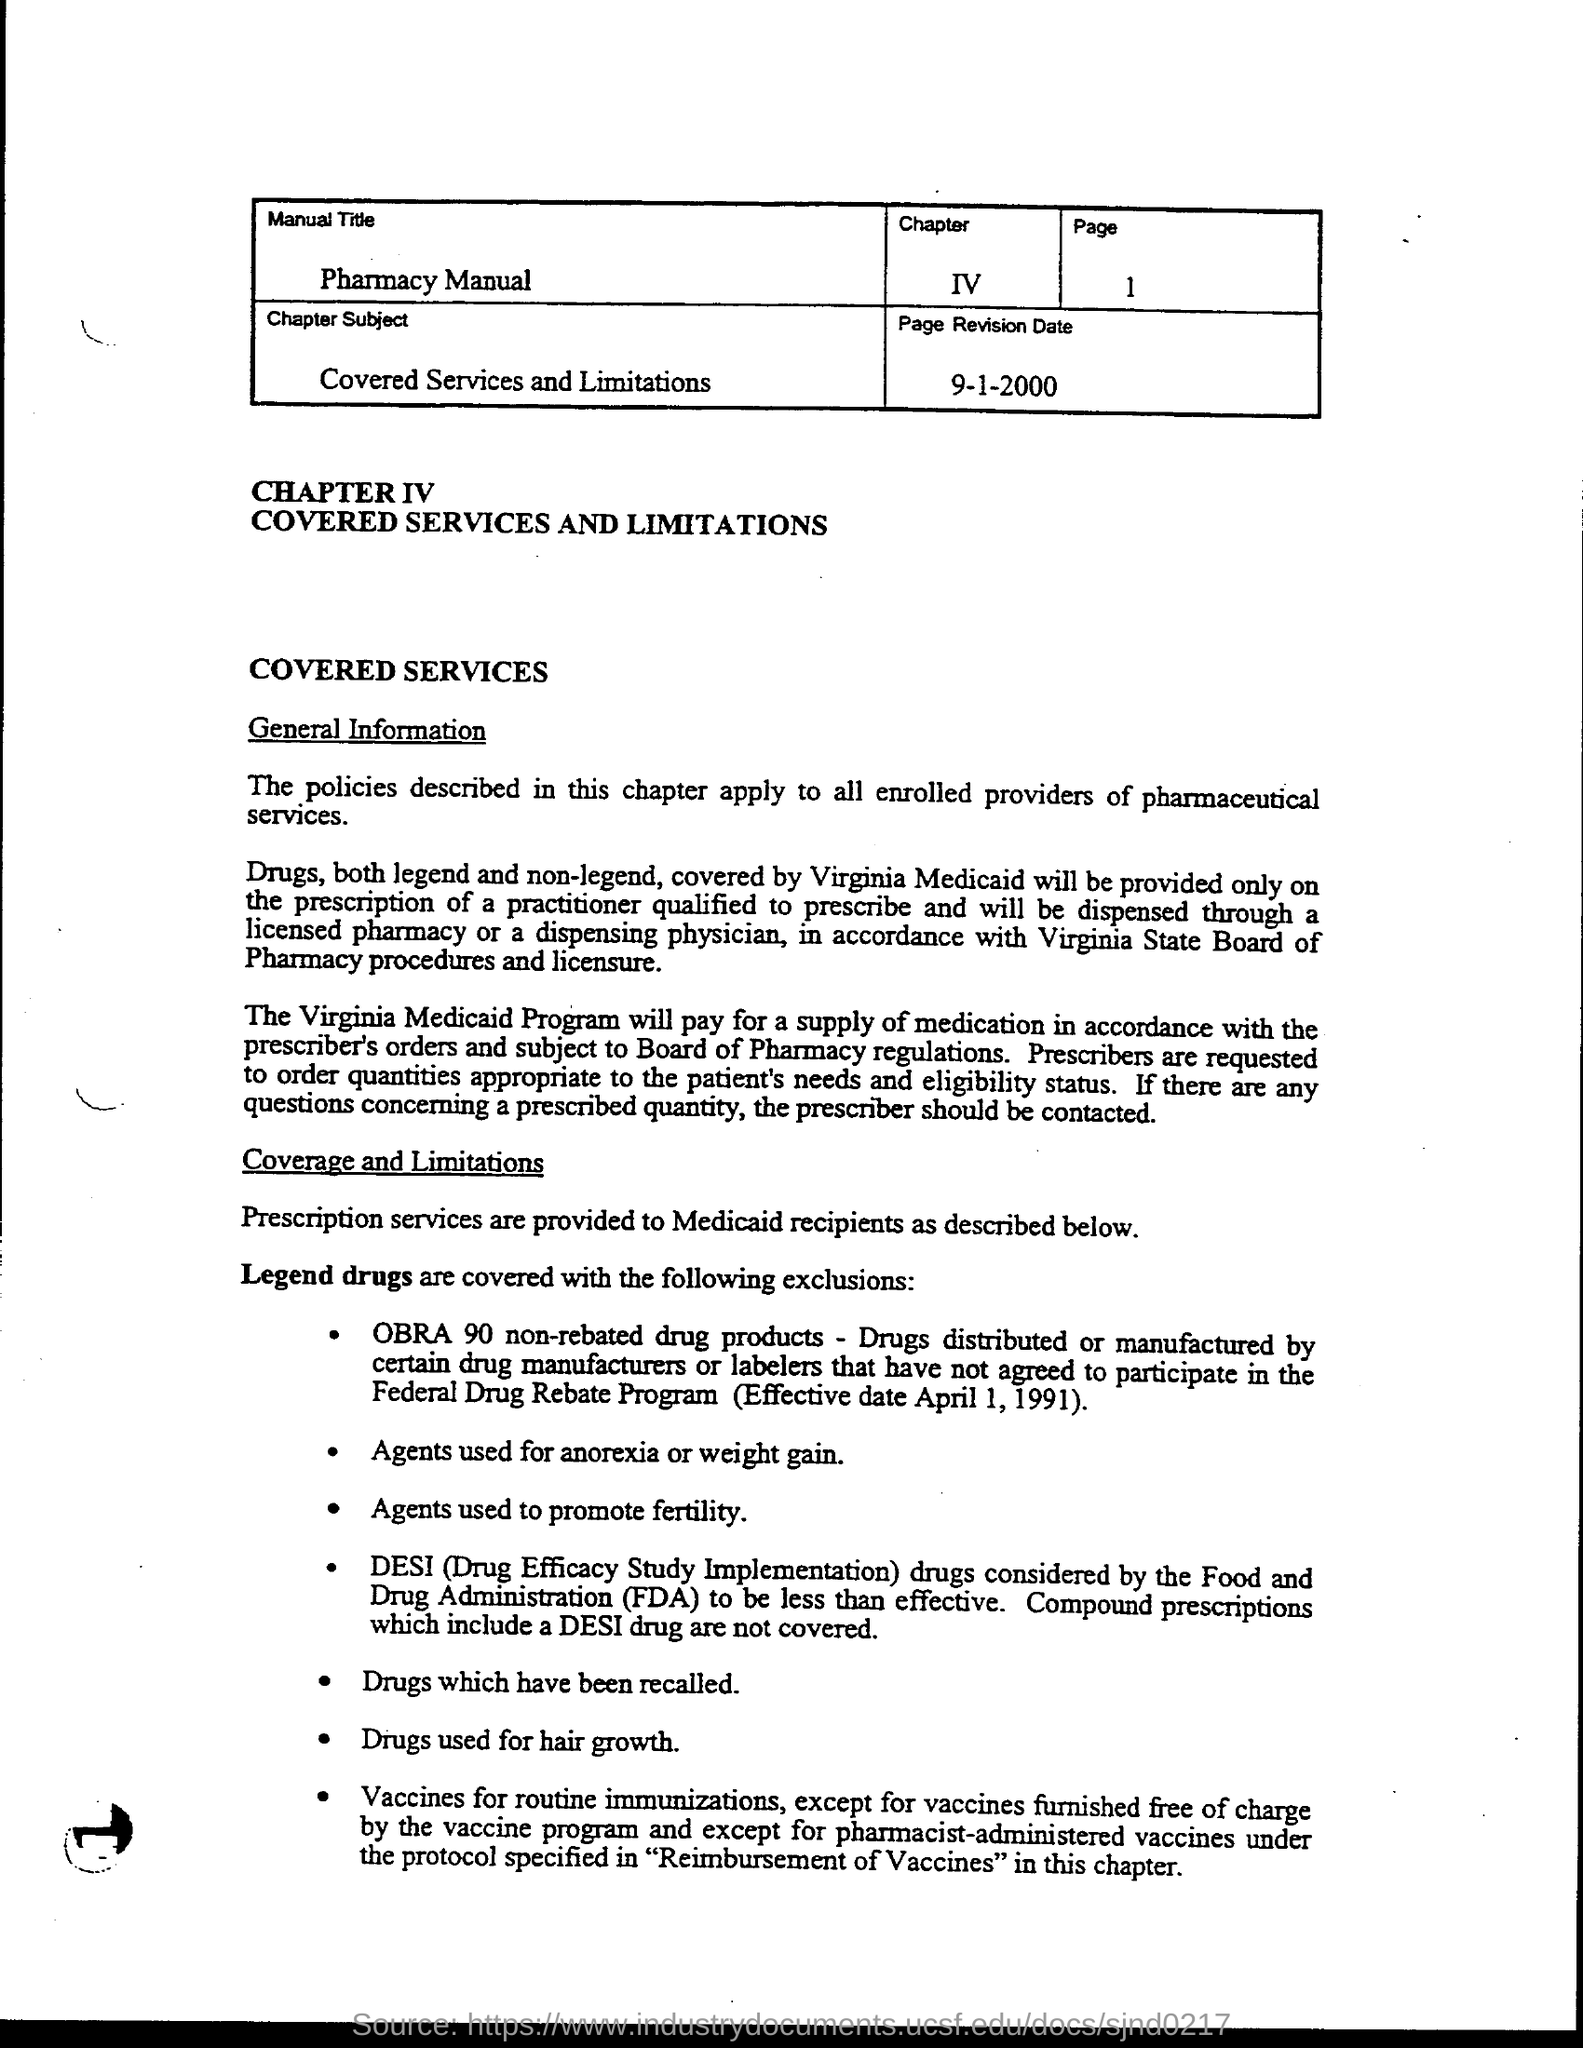Specify some key components in this picture. DESI stands for "Drug Efficacy Study Implementation. The page number is 1, and it continues up to 1. The manual title is the Pharmacy Manual. The Food and Drug Administration, commonly abbreviated as FDA, is a government agency responsible for regulating and overseeing the safety of food and pharmaceutical drugs in the United States. The chapter covers the subject of 'What is the chapter subject?' and also provides information on the 'Covered services and limitations.' 